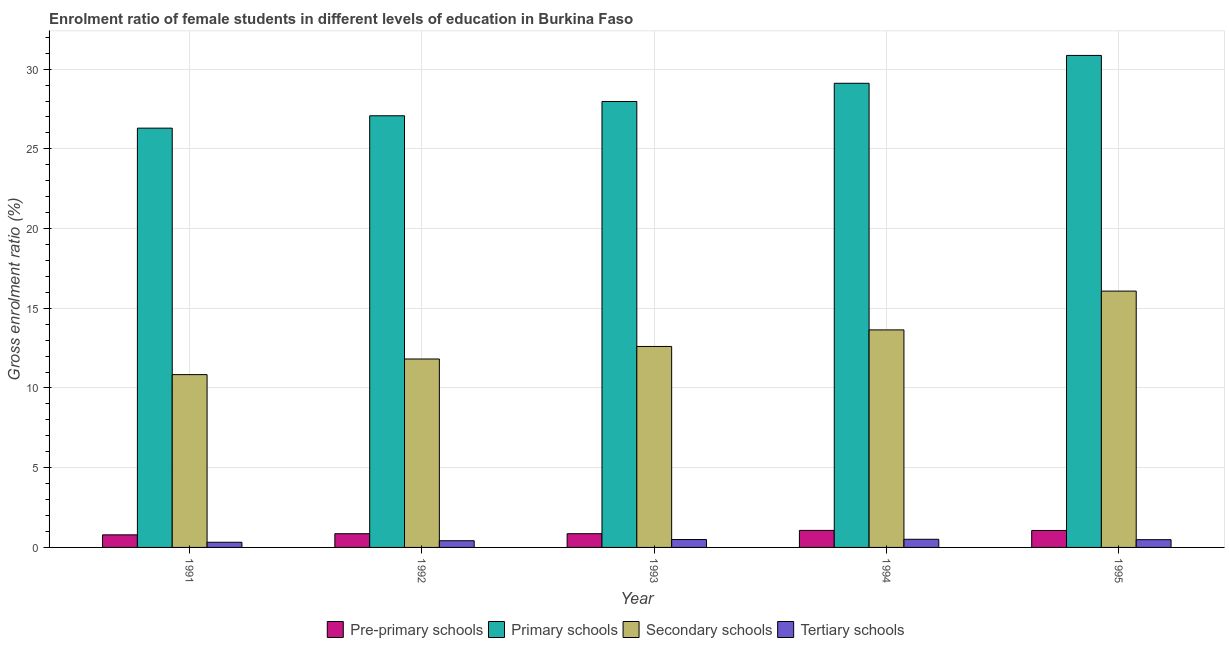Are the number of bars per tick equal to the number of legend labels?
Offer a very short reply. Yes. How many bars are there on the 5th tick from the left?
Provide a short and direct response. 4. How many bars are there on the 2nd tick from the right?
Offer a terse response. 4. What is the gross enrolment ratio(male) in tertiary schools in 1993?
Your answer should be very brief. 0.49. Across all years, what is the maximum gross enrolment ratio(male) in pre-primary schools?
Keep it short and to the point. 1.07. Across all years, what is the minimum gross enrolment ratio(male) in secondary schools?
Your answer should be compact. 10.84. In which year was the gross enrolment ratio(male) in pre-primary schools maximum?
Keep it short and to the point. 1994. In which year was the gross enrolment ratio(male) in secondary schools minimum?
Your answer should be compact. 1991. What is the total gross enrolment ratio(male) in secondary schools in the graph?
Your answer should be compact. 64.98. What is the difference between the gross enrolment ratio(male) in tertiary schools in 1992 and that in 1993?
Give a very brief answer. -0.08. What is the difference between the gross enrolment ratio(male) in tertiary schools in 1992 and the gross enrolment ratio(male) in secondary schools in 1991?
Offer a terse response. 0.1. What is the average gross enrolment ratio(male) in primary schools per year?
Offer a very short reply. 28.26. In how many years, is the gross enrolment ratio(male) in tertiary schools greater than 30 %?
Your response must be concise. 0. What is the ratio of the gross enrolment ratio(male) in primary schools in 1992 to that in 1995?
Keep it short and to the point. 0.88. What is the difference between the highest and the second highest gross enrolment ratio(male) in secondary schools?
Offer a very short reply. 2.43. What is the difference between the highest and the lowest gross enrolment ratio(male) in primary schools?
Your answer should be very brief. 4.56. What does the 2nd bar from the left in 1991 represents?
Provide a short and direct response. Primary schools. What does the 2nd bar from the right in 1995 represents?
Your answer should be very brief. Secondary schools. How many bars are there?
Keep it short and to the point. 20. Are all the bars in the graph horizontal?
Make the answer very short. No. What is the difference between two consecutive major ticks on the Y-axis?
Your answer should be very brief. 5. Does the graph contain grids?
Offer a very short reply. Yes. How are the legend labels stacked?
Your answer should be very brief. Horizontal. What is the title of the graph?
Ensure brevity in your answer.  Enrolment ratio of female students in different levels of education in Burkina Faso. Does "Sweden" appear as one of the legend labels in the graph?
Your answer should be compact. No. What is the Gross enrolment ratio (%) in Pre-primary schools in 1991?
Provide a short and direct response. 0.79. What is the Gross enrolment ratio (%) of Primary schools in 1991?
Ensure brevity in your answer.  26.3. What is the Gross enrolment ratio (%) in Secondary schools in 1991?
Provide a short and direct response. 10.84. What is the Gross enrolment ratio (%) of Tertiary schools in 1991?
Provide a short and direct response. 0.32. What is the Gross enrolment ratio (%) of Pre-primary schools in 1992?
Offer a very short reply. 0.86. What is the Gross enrolment ratio (%) in Primary schools in 1992?
Your response must be concise. 27.07. What is the Gross enrolment ratio (%) of Secondary schools in 1992?
Make the answer very short. 11.82. What is the Gross enrolment ratio (%) in Tertiary schools in 1992?
Provide a short and direct response. 0.42. What is the Gross enrolment ratio (%) of Pre-primary schools in 1993?
Give a very brief answer. 0.86. What is the Gross enrolment ratio (%) in Primary schools in 1993?
Provide a succinct answer. 27.97. What is the Gross enrolment ratio (%) in Secondary schools in 1993?
Your answer should be compact. 12.61. What is the Gross enrolment ratio (%) of Tertiary schools in 1993?
Offer a very short reply. 0.49. What is the Gross enrolment ratio (%) in Pre-primary schools in 1994?
Provide a succinct answer. 1.07. What is the Gross enrolment ratio (%) of Primary schools in 1994?
Your answer should be very brief. 29.11. What is the Gross enrolment ratio (%) in Secondary schools in 1994?
Provide a succinct answer. 13.64. What is the Gross enrolment ratio (%) of Tertiary schools in 1994?
Make the answer very short. 0.51. What is the Gross enrolment ratio (%) of Pre-primary schools in 1995?
Provide a short and direct response. 1.06. What is the Gross enrolment ratio (%) in Primary schools in 1995?
Provide a succinct answer. 30.86. What is the Gross enrolment ratio (%) in Secondary schools in 1995?
Offer a very short reply. 16.08. What is the Gross enrolment ratio (%) of Tertiary schools in 1995?
Keep it short and to the point. 0.49. Across all years, what is the maximum Gross enrolment ratio (%) in Pre-primary schools?
Your answer should be compact. 1.07. Across all years, what is the maximum Gross enrolment ratio (%) of Primary schools?
Ensure brevity in your answer.  30.86. Across all years, what is the maximum Gross enrolment ratio (%) of Secondary schools?
Keep it short and to the point. 16.08. Across all years, what is the maximum Gross enrolment ratio (%) in Tertiary schools?
Your response must be concise. 0.51. Across all years, what is the minimum Gross enrolment ratio (%) in Pre-primary schools?
Your answer should be compact. 0.79. Across all years, what is the minimum Gross enrolment ratio (%) in Primary schools?
Offer a terse response. 26.3. Across all years, what is the minimum Gross enrolment ratio (%) in Secondary schools?
Ensure brevity in your answer.  10.84. Across all years, what is the minimum Gross enrolment ratio (%) in Tertiary schools?
Provide a short and direct response. 0.32. What is the total Gross enrolment ratio (%) in Pre-primary schools in the graph?
Give a very brief answer. 4.64. What is the total Gross enrolment ratio (%) of Primary schools in the graph?
Your answer should be compact. 141.31. What is the total Gross enrolment ratio (%) of Secondary schools in the graph?
Provide a short and direct response. 64.98. What is the total Gross enrolment ratio (%) of Tertiary schools in the graph?
Your answer should be very brief. 2.23. What is the difference between the Gross enrolment ratio (%) of Pre-primary schools in 1991 and that in 1992?
Ensure brevity in your answer.  -0.07. What is the difference between the Gross enrolment ratio (%) in Primary schools in 1991 and that in 1992?
Ensure brevity in your answer.  -0.78. What is the difference between the Gross enrolment ratio (%) of Secondary schools in 1991 and that in 1992?
Make the answer very short. -0.98. What is the difference between the Gross enrolment ratio (%) of Tertiary schools in 1991 and that in 1992?
Your answer should be very brief. -0.1. What is the difference between the Gross enrolment ratio (%) of Pre-primary schools in 1991 and that in 1993?
Your answer should be very brief. -0.07. What is the difference between the Gross enrolment ratio (%) in Primary schools in 1991 and that in 1993?
Offer a terse response. -1.67. What is the difference between the Gross enrolment ratio (%) of Secondary schools in 1991 and that in 1993?
Make the answer very short. -1.77. What is the difference between the Gross enrolment ratio (%) in Tertiary schools in 1991 and that in 1993?
Offer a terse response. -0.17. What is the difference between the Gross enrolment ratio (%) of Pre-primary schools in 1991 and that in 1994?
Keep it short and to the point. -0.28. What is the difference between the Gross enrolment ratio (%) in Primary schools in 1991 and that in 1994?
Provide a succinct answer. -2.81. What is the difference between the Gross enrolment ratio (%) in Secondary schools in 1991 and that in 1994?
Keep it short and to the point. -2.8. What is the difference between the Gross enrolment ratio (%) in Tertiary schools in 1991 and that in 1994?
Your answer should be compact. -0.19. What is the difference between the Gross enrolment ratio (%) of Pre-primary schools in 1991 and that in 1995?
Your response must be concise. -0.28. What is the difference between the Gross enrolment ratio (%) of Primary schools in 1991 and that in 1995?
Offer a terse response. -4.56. What is the difference between the Gross enrolment ratio (%) of Secondary schools in 1991 and that in 1995?
Offer a terse response. -5.24. What is the difference between the Gross enrolment ratio (%) of Tertiary schools in 1991 and that in 1995?
Make the answer very short. -0.16. What is the difference between the Gross enrolment ratio (%) in Pre-primary schools in 1992 and that in 1993?
Make the answer very short. -0. What is the difference between the Gross enrolment ratio (%) in Primary schools in 1992 and that in 1993?
Offer a terse response. -0.9. What is the difference between the Gross enrolment ratio (%) of Secondary schools in 1992 and that in 1993?
Give a very brief answer. -0.79. What is the difference between the Gross enrolment ratio (%) of Tertiary schools in 1992 and that in 1993?
Ensure brevity in your answer.  -0.08. What is the difference between the Gross enrolment ratio (%) of Pre-primary schools in 1992 and that in 1994?
Ensure brevity in your answer.  -0.21. What is the difference between the Gross enrolment ratio (%) in Primary schools in 1992 and that in 1994?
Your answer should be compact. -2.04. What is the difference between the Gross enrolment ratio (%) of Secondary schools in 1992 and that in 1994?
Give a very brief answer. -1.82. What is the difference between the Gross enrolment ratio (%) of Tertiary schools in 1992 and that in 1994?
Keep it short and to the point. -0.09. What is the difference between the Gross enrolment ratio (%) in Pre-primary schools in 1992 and that in 1995?
Your answer should be compact. -0.2. What is the difference between the Gross enrolment ratio (%) of Primary schools in 1992 and that in 1995?
Your response must be concise. -3.79. What is the difference between the Gross enrolment ratio (%) of Secondary schools in 1992 and that in 1995?
Your answer should be compact. -4.26. What is the difference between the Gross enrolment ratio (%) of Tertiary schools in 1992 and that in 1995?
Your answer should be very brief. -0.07. What is the difference between the Gross enrolment ratio (%) of Pre-primary schools in 1993 and that in 1994?
Keep it short and to the point. -0.21. What is the difference between the Gross enrolment ratio (%) of Primary schools in 1993 and that in 1994?
Give a very brief answer. -1.14. What is the difference between the Gross enrolment ratio (%) in Secondary schools in 1993 and that in 1994?
Your answer should be very brief. -1.04. What is the difference between the Gross enrolment ratio (%) in Tertiary schools in 1993 and that in 1994?
Ensure brevity in your answer.  -0.02. What is the difference between the Gross enrolment ratio (%) of Pre-primary schools in 1993 and that in 1995?
Offer a very short reply. -0.2. What is the difference between the Gross enrolment ratio (%) of Primary schools in 1993 and that in 1995?
Give a very brief answer. -2.89. What is the difference between the Gross enrolment ratio (%) of Secondary schools in 1993 and that in 1995?
Your response must be concise. -3.47. What is the difference between the Gross enrolment ratio (%) of Tertiary schools in 1993 and that in 1995?
Offer a terse response. 0.01. What is the difference between the Gross enrolment ratio (%) of Pre-primary schools in 1994 and that in 1995?
Your answer should be very brief. 0. What is the difference between the Gross enrolment ratio (%) of Primary schools in 1994 and that in 1995?
Offer a terse response. -1.75. What is the difference between the Gross enrolment ratio (%) of Secondary schools in 1994 and that in 1995?
Ensure brevity in your answer.  -2.43. What is the difference between the Gross enrolment ratio (%) in Tertiary schools in 1994 and that in 1995?
Your response must be concise. 0.02. What is the difference between the Gross enrolment ratio (%) of Pre-primary schools in 1991 and the Gross enrolment ratio (%) of Primary schools in 1992?
Provide a short and direct response. -26.29. What is the difference between the Gross enrolment ratio (%) in Pre-primary schools in 1991 and the Gross enrolment ratio (%) in Secondary schools in 1992?
Provide a succinct answer. -11.03. What is the difference between the Gross enrolment ratio (%) of Pre-primary schools in 1991 and the Gross enrolment ratio (%) of Tertiary schools in 1992?
Keep it short and to the point. 0.37. What is the difference between the Gross enrolment ratio (%) of Primary schools in 1991 and the Gross enrolment ratio (%) of Secondary schools in 1992?
Your answer should be compact. 14.48. What is the difference between the Gross enrolment ratio (%) of Primary schools in 1991 and the Gross enrolment ratio (%) of Tertiary schools in 1992?
Offer a very short reply. 25.88. What is the difference between the Gross enrolment ratio (%) in Secondary schools in 1991 and the Gross enrolment ratio (%) in Tertiary schools in 1992?
Keep it short and to the point. 10.42. What is the difference between the Gross enrolment ratio (%) in Pre-primary schools in 1991 and the Gross enrolment ratio (%) in Primary schools in 1993?
Give a very brief answer. -27.18. What is the difference between the Gross enrolment ratio (%) of Pre-primary schools in 1991 and the Gross enrolment ratio (%) of Secondary schools in 1993?
Your answer should be very brief. -11.82. What is the difference between the Gross enrolment ratio (%) in Pre-primary schools in 1991 and the Gross enrolment ratio (%) in Tertiary schools in 1993?
Your response must be concise. 0.29. What is the difference between the Gross enrolment ratio (%) of Primary schools in 1991 and the Gross enrolment ratio (%) of Secondary schools in 1993?
Offer a terse response. 13.69. What is the difference between the Gross enrolment ratio (%) in Primary schools in 1991 and the Gross enrolment ratio (%) in Tertiary schools in 1993?
Your answer should be very brief. 25.8. What is the difference between the Gross enrolment ratio (%) of Secondary schools in 1991 and the Gross enrolment ratio (%) of Tertiary schools in 1993?
Your response must be concise. 10.34. What is the difference between the Gross enrolment ratio (%) of Pre-primary schools in 1991 and the Gross enrolment ratio (%) of Primary schools in 1994?
Your answer should be very brief. -28.32. What is the difference between the Gross enrolment ratio (%) of Pre-primary schools in 1991 and the Gross enrolment ratio (%) of Secondary schools in 1994?
Give a very brief answer. -12.85. What is the difference between the Gross enrolment ratio (%) of Pre-primary schools in 1991 and the Gross enrolment ratio (%) of Tertiary schools in 1994?
Your answer should be very brief. 0.28. What is the difference between the Gross enrolment ratio (%) in Primary schools in 1991 and the Gross enrolment ratio (%) in Secondary schools in 1994?
Your answer should be compact. 12.65. What is the difference between the Gross enrolment ratio (%) in Primary schools in 1991 and the Gross enrolment ratio (%) in Tertiary schools in 1994?
Your answer should be very brief. 25.79. What is the difference between the Gross enrolment ratio (%) of Secondary schools in 1991 and the Gross enrolment ratio (%) of Tertiary schools in 1994?
Provide a succinct answer. 10.33. What is the difference between the Gross enrolment ratio (%) of Pre-primary schools in 1991 and the Gross enrolment ratio (%) of Primary schools in 1995?
Your response must be concise. -30.07. What is the difference between the Gross enrolment ratio (%) in Pre-primary schools in 1991 and the Gross enrolment ratio (%) in Secondary schools in 1995?
Ensure brevity in your answer.  -15.29. What is the difference between the Gross enrolment ratio (%) of Pre-primary schools in 1991 and the Gross enrolment ratio (%) of Tertiary schools in 1995?
Your response must be concise. 0.3. What is the difference between the Gross enrolment ratio (%) in Primary schools in 1991 and the Gross enrolment ratio (%) in Secondary schools in 1995?
Offer a terse response. 10.22. What is the difference between the Gross enrolment ratio (%) of Primary schools in 1991 and the Gross enrolment ratio (%) of Tertiary schools in 1995?
Provide a succinct answer. 25.81. What is the difference between the Gross enrolment ratio (%) in Secondary schools in 1991 and the Gross enrolment ratio (%) in Tertiary schools in 1995?
Provide a short and direct response. 10.35. What is the difference between the Gross enrolment ratio (%) of Pre-primary schools in 1992 and the Gross enrolment ratio (%) of Primary schools in 1993?
Offer a terse response. -27.11. What is the difference between the Gross enrolment ratio (%) in Pre-primary schools in 1992 and the Gross enrolment ratio (%) in Secondary schools in 1993?
Offer a very short reply. -11.75. What is the difference between the Gross enrolment ratio (%) in Pre-primary schools in 1992 and the Gross enrolment ratio (%) in Tertiary schools in 1993?
Your response must be concise. 0.37. What is the difference between the Gross enrolment ratio (%) of Primary schools in 1992 and the Gross enrolment ratio (%) of Secondary schools in 1993?
Provide a succinct answer. 14.47. What is the difference between the Gross enrolment ratio (%) of Primary schools in 1992 and the Gross enrolment ratio (%) of Tertiary schools in 1993?
Provide a short and direct response. 26.58. What is the difference between the Gross enrolment ratio (%) in Secondary schools in 1992 and the Gross enrolment ratio (%) in Tertiary schools in 1993?
Provide a succinct answer. 11.32. What is the difference between the Gross enrolment ratio (%) of Pre-primary schools in 1992 and the Gross enrolment ratio (%) of Primary schools in 1994?
Offer a terse response. -28.25. What is the difference between the Gross enrolment ratio (%) in Pre-primary schools in 1992 and the Gross enrolment ratio (%) in Secondary schools in 1994?
Your answer should be compact. -12.78. What is the difference between the Gross enrolment ratio (%) of Pre-primary schools in 1992 and the Gross enrolment ratio (%) of Tertiary schools in 1994?
Ensure brevity in your answer.  0.35. What is the difference between the Gross enrolment ratio (%) of Primary schools in 1992 and the Gross enrolment ratio (%) of Secondary schools in 1994?
Keep it short and to the point. 13.43. What is the difference between the Gross enrolment ratio (%) in Primary schools in 1992 and the Gross enrolment ratio (%) in Tertiary schools in 1994?
Your response must be concise. 26.56. What is the difference between the Gross enrolment ratio (%) in Secondary schools in 1992 and the Gross enrolment ratio (%) in Tertiary schools in 1994?
Make the answer very short. 11.31. What is the difference between the Gross enrolment ratio (%) in Pre-primary schools in 1992 and the Gross enrolment ratio (%) in Primary schools in 1995?
Provide a succinct answer. -30. What is the difference between the Gross enrolment ratio (%) in Pre-primary schools in 1992 and the Gross enrolment ratio (%) in Secondary schools in 1995?
Make the answer very short. -15.22. What is the difference between the Gross enrolment ratio (%) in Pre-primary schools in 1992 and the Gross enrolment ratio (%) in Tertiary schools in 1995?
Your answer should be compact. 0.37. What is the difference between the Gross enrolment ratio (%) in Primary schools in 1992 and the Gross enrolment ratio (%) in Secondary schools in 1995?
Offer a very short reply. 11. What is the difference between the Gross enrolment ratio (%) of Primary schools in 1992 and the Gross enrolment ratio (%) of Tertiary schools in 1995?
Give a very brief answer. 26.59. What is the difference between the Gross enrolment ratio (%) in Secondary schools in 1992 and the Gross enrolment ratio (%) in Tertiary schools in 1995?
Offer a very short reply. 11.33. What is the difference between the Gross enrolment ratio (%) of Pre-primary schools in 1993 and the Gross enrolment ratio (%) of Primary schools in 1994?
Your answer should be very brief. -28.25. What is the difference between the Gross enrolment ratio (%) in Pre-primary schools in 1993 and the Gross enrolment ratio (%) in Secondary schools in 1994?
Your response must be concise. -12.78. What is the difference between the Gross enrolment ratio (%) of Pre-primary schools in 1993 and the Gross enrolment ratio (%) of Tertiary schools in 1994?
Ensure brevity in your answer.  0.35. What is the difference between the Gross enrolment ratio (%) of Primary schools in 1993 and the Gross enrolment ratio (%) of Secondary schools in 1994?
Provide a succinct answer. 14.33. What is the difference between the Gross enrolment ratio (%) of Primary schools in 1993 and the Gross enrolment ratio (%) of Tertiary schools in 1994?
Provide a succinct answer. 27.46. What is the difference between the Gross enrolment ratio (%) in Secondary schools in 1993 and the Gross enrolment ratio (%) in Tertiary schools in 1994?
Keep it short and to the point. 12.09. What is the difference between the Gross enrolment ratio (%) in Pre-primary schools in 1993 and the Gross enrolment ratio (%) in Primary schools in 1995?
Offer a very short reply. -30. What is the difference between the Gross enrolment ratio (%) of Pre-primary schools in 1993 and the Gross enrolment ratio (%) of Secondary schools in 1995?
Make the answer very short. -15.22. What is the difference between the Gross enrolment ratio (%) in Pre-primary schools in 1993 and the Gross enrolment ratio (%) in Tertiary schools in 1995?
Ensure brevity in your answer.  0.38. What is the difference between the Gross enrolment ratio (%) of Primary schools in 1993 and the Gross enrolment ratio (%) of Secondary schools in 1995?
Provide a short and direct response. 11.89. What is the difference between the Gross enrolment ratio (%) of Primary schools in 1993 and the Gross enrolment ratio (%) of Tertiary schools in 1995?
Your response must be concise. 27.48. What is the difference between the Gross enrolment ratio (%) in Secondary schools in 1993 and the Gross enrolment ratio (%) in Tertiary schools in 1995?
Your response must be concise. 12.12. What is the difference between the Gross enrolment ratio (%) of Pre-primary schools in 1994 and the Gross enrolment ratio (%) of Primary schools in 1995?
Give a very brief answer. -29.79. What is the difference between the Gross enrolment ratio (%) in Pre-primary schools in 1994 and the Gross enrolment ratio (%) in Secondary schools in 1995?
Your answer should be compact. -15.01. What is the difference between the Gross enrolment ratio (%) in Pre-primary schools in 1994 and the Gross enrolment ratio (%) in Tertiary schools in 1995?
Provide a short and direct response. 0.58. What is the difference between the Gross enrolment ratio (%) of Primary schools in 1994 and the Gross enrolment ratio (%) of Secondary schools in 1995?
Make the answer very short. 13.03. What is the difference between the Gross enrolment ratio (%) in Primary schools in 1994 and the Gross enrolment ratio (%) in Tertiary schools in 1995?
Make the answer very short. 28.63. What is the difference between the Gross enrolment ratio (%) of Secondary schools in 1994 and the Gross enrolment ratio (%) of Tertiary schools in 1995?
Make the answer very short. 13.16. What is the average Gross enrolment ratio (%) in Pre-primary schools per year?
Provide a short and direct response. 0.93. What is the average Gross enrolment ratio (%) of Primary schools per year?
Provide a succinct answer. 28.26. What is the average Gross enrolment ratio (%) of Secondary schools per year?
Give a very brief answer. 13. What is the average Gross enrolment ratio (%) in Tertiary schools per year?
Keep it short and to the point. 0.45. In the year 1991, what is the difference between the Gross enrolment ratio (%) in Pre-primary schools and Gross enrolment ratio (%) in Primary schools?
Your response must be concise. -25.51. In the year 1991, what is the difference between the Gross enrolment ratio (%) in Pre-primary schools and Gross enrolment ratio (%) in Secondary schools?
Provide a short and direct response. -10.05. In the year 1991, what is the difference between the Gross enrolment ratio (%) in Pre-primary schools and Gross enrolment ratio (%) in Tertiary schools?
Your response must be concise. 0.46. In the year 1991, what is the difference between the Gross enrolment ratio (%) of Primary schools and Gross enrolment ratio (%) of Secondary schools?
Make the answer very short. 15.46. In the year 1991, what is the difference between the Gross enrolment ratio (%) of Primary schools and Gross enrolment ratio (%) of Tertiary schools?
Your answer should be compact. 25.97. In the year 1991, what is the difference between the Gross enrolment ratio (%) of Secondary schools and Gross enrolment ratio (%) of Tertiary schools?
Provide a short and direct response. 10.51. In the year 1992, what is the difference between the Gross enrolment ratio (%) of Pre-primary schools and Gross enrolment ratio (%) of Primary schools?
Make the answer very short. -26.21. In the year 1992, what is the difference between the Gross enrolment ratio (%) of Pre-primary schools and Gross enrolment ratio (%) of Secondary schools?
Give a very brief answer. -10.96. In the year 1992, what is the difference between the Gross enrolment ratio (%) of Pre-primary schools and Gross enrolment ratio (%) of Tertiary schools?
Ensure brevity in your answer.  0.44. In the year 1992, what is the difference between the Gross enrolment ratio (%) in Primary schools and Gross enrolment ratio (%) in Secondary schools?
Your answer should be very brief. 15.26. In the year 1992, what is the difference between the Gross enrolment ratio (%) in Primary schools and Gross enrolment ratio (%) in Tertiary schools?
Provide a succinct answer. 26.65. In the year 1992, what is the difference between the Gross enrolment ratio (%) in Secondary schools and Gross enrolment ratio (%) in Tertiary schools?
Your answer should be very brief. 11.4. In the year 1993, what is the difference between the Gross enrolment ratio (%) of Pre-primary schools and Gross enrolment ratio (%) of Primary schools?
Provide a short and direct response. -27.11. In the year 1993, what is the difference between the Gross enrolment ratio (%) of Pre-primary schools and Gross enrolment ratio (%) of Secondary schools?
Your answer should be compact. -11.74. In the year 1993, what is the difference between the Gross enrolment ratio (%) of Pre-primary schools and Gross enrolment ratio (%) of Tertiary schools?
Keep it short and to the point. 0.37. In the year 1993, what is the difference between the Gross enrolment ratio (%) of Primary schools and Gross enrolment ratio (%) of Secondary schools?
Keep it short and to the point. 15.37. In the year 1993, what is the difference between the Gross enrolment ratio (%) in Primary schools and Gross enrolment ratio (%) in Tertiary schools?
Give a very brief answer. 27.48. In the year 1993, what is the difference between the Gross enrolment ratio (%) in Secondary schools and Gross enrolment ratio (%) in Tertiary schools?
Give a very brief answer. 12.11. In the year 1994, what is the difference between the Gross enrolment ratio (%) of Pre-primary schools and Gross enrolment ratio (%) of Primary schools?
Your answer should be compact. -28.04. In the year 1994, what is the difference between the Gross enrolment ratio (%) of Pre-primary schools and Gross enrolment ratio (%) of Secondary schools?
Give a very brief answer. -12.57. In the year 1994, what is the difference between the Gross enrolment ratio (%) of Pre-primary schools and Gross enrolment ratio (%) of Tertiary schools?
Give a very brief answer. 0.56. In the year 1994, what is the difference between the Gross enrolment ratio (%) of Primary schools and Gross enrolment ratio (%) of Secondary schools?
Provide a short and direct response. 15.47. In the year 1994, what is the difference between the Gross enrolment ratio (%) in Primary schools and Gross enrolment ratio (%) in Tertiary schools?
Keep it short and to the point. 28.6. In the year 1994, what is the difference between the Gross enrolment ratio (%) in Secondary schools and Gross enrolment ratio (%) in Tertiary schools?
Your answer should be very brief. 13.13. In the year 1995, what is the difference between the Gross enrolment ratio (%) of Pre-primary schools and Gross enrolment ratio (%) of Primary schools?
Offer a terse response. -29.79. In the year 1995, what is the difference between the Gross enrolment ratio (%) in Pre-primary schools and Gross enrolment ratio (%) in Secondary schools?
Keep it short and to the point. -15.01. In the year 1995, what is the difference between the Gross enrolment ratio (%) in Pre-primary schools and Gross enrolment ratio (%) in Tertiary schools?
Your response must be concise. 0.58. In the year 1995, what is the difference between the Gross enrolment ratio (%) in Primary schools and Gross enrolment ratio (%) in Secondary schools?
Your answer should be very brief. 14.78. In the year 1995, what is the difference between the Gross enrolment ratio (%) of Primary schools and Gross enrolment ratio (%) of Tertiary schools?
Keep it short and to the point. 30.37. In the year 1995, what is the difference between the Gross enrolment ratio (%) of Secondary schools and Gross enrolment ratio (%) of Tertiary schools?
Keep it short and to the point. 15.59. What is the ratio of the Gross enrolment ratio (%) of Pre-primary schools in 1991 to that in 1992?
Give a very brief answer. 0.92. What is the ratio of the Gross enrolment ratio (%) in Primary schools in 1991 to that in 1992?
Offer a very short reply. 0.97. What is the ratio of the Gross enrolment ratio (%) in Secondary schools in 1991 to that in 1992?
Your answer should be very brief. 0.92. What is the ratio of the Gross enrolment ratio (%) in Tertiary schools in 1991 to that in 1992?
Provide a short and direct response. 0.77. What is the ratio of the Gross enrolment ratio (%) of Pre-primary schools in 1991 to that in 1993?
Your answer should be compact. 0.92. What is the ratio of the Gross enrolment ratio (%) in Primary schools in 1991 to that in 1993?
Your answer should be very brief. 0.94. What is the ratio of the Gross enrolment ratio (%) of Secondary schools in 1991 to that in 1993?
Give a very brief answer. 0.86. What is the ratio of the Gross enrolment ratio (%) in Tertiary schools in 1991 to that in 1993?
Provide a short and direct response. 0.65. What is the ratio of the Gross enrolment ratio (%) of Pre-primary schools in 1991 to that in 1994?
Make the answer very short. 0.74. What is the ratio of the Gross enrolment ratio (%) in Primary schools in 1991 to that in 1994?
Keep it short and to the point. 0.9. What is the ratio of the Gross enrolment ratio (%) in Secondary schools in 1991 to that in 1994?
Your response must be concise. 0.79. What is the ratio of the Gross enrolment ratio (%) in Tertiary schools in 1991 to that in 1994?
Give a very brief answer. 0.63. What is the ratio of the Gross enrolment ratio (%) of Pre-primary schools in 1991 to that in 1995?
Provide a succinct answer. 0.74. What is the ratio of the Gross enrolment ratio (%) of Primary schools in 1991 to that in 1995?
Give a very brief answer. 0.85. What is the ratio of the Gross enrolment ratio (%) in Secondary schools in 1991 to that in 1995?
Keep it short and to the point. 0.67. What is the ratio of the Gross enrolment ratio (%) in Tertiary schools in 1991 to that in 1995?
Offer a terse response. 0.67. What is the ratio of the Gross enrolment ratio (%) in Secondary schools in 1992 to that in 1993?
Your answer should be compact. 0.94. What is the ratio of the Gross enrolment ratio (%) in Tertiary schools in 1992 to that in 1993?
Your answer should be very brief. 0.85. What is the ratio of the Gross enrolment ratio (%) in Pre-primary schools in 1992 to that in 1994?
Give a very brief answer. 0.8. What is the ratio of the Gross enrolment ratio (%) of Primary schools in 1992 to that in 1994?
Your response must be concise. 0.93. What is the ratio of the Gross enrolment ratio (%) of Secondary schools in 1992 to that in 1994?
Make the answer very short. 0.87. What is the ratio of the Gross enrolment ratio (%) in Tertiary schools in 1992 to that in 1994?
Your answer should be very brief. 0.82. What is the ratio of the Gross enrolment ratio (%) in Pre-primary schools in 1992 to that in 1995?
Your answer should be very brief. 0.81. What is the ratio of the Gross enrolment ratio (%) of Primary schools in 1992 to that in 1995?
Your answer should be compact. 0.88. What is the ratio of the Gross enrolment ratio (%) in Secondary schools in 1992 to that in 1995?
Keep it short and to the point. 0.74. What is the ratio of the Gross enrolment ratio (%) in Tertiary schools in 1992 to that in 1995?
Give a very brief answer. 0.86. What is the ratio of the Gross enrolment ratio (%) in Pre-primary schools in 1993 to that in 1994?
Your answer should be compact. 0.81. What is the ratio of the Gross enrolment ratio (%) in Primary schools in 1993 to that in 1994?
Offer a terse response. 0.96. What is the ratio of the Gross enrolment ratio (%) in Secondary schools in 1993 to that in 1994?
Keep it short and to the point. 0.92. What is the ratio of the Gross enrolment ratio (%) in Pre-primary schools in 1993 to that in 1995?
Provide a succinct answer. 0.81. What is the ratio of the Gross enrolment ratio (%) of Primary schools in 1993 to that in 1995?
Offer a very short reply. 0.91. What is the ratio of the Gross enrolment ratio (%) in Secondary schools in 1993 to that in 1995?
Offer a terse response. 0.78. What is the ratio of the Gross enrolment ratio (%) of Tertiary schools in 1993 to that in 1995?
Provide a succinct answer. 1.02. What is the ratio of the Gross enrolment ratio (%) in Pre-primary schools in 1994 to that in 1995?
Your response must be concise. 1. What is the ratio of the Gross enrolment ratio (%) in Primary schools in 1994 to that in 1995?
Offer a terse response. 0.94. What is the ratio of the Gross enrolment ratio (%) of Secondary schools in 1994 to that in 1995?
Your answer should be very brief. 0.85. What is the ratio of the Gross enrolment ratio (%) of Tertiary schools in 1994 to that in 1995?
Your answer should be very brief. 1.05. What is the difference between the highest and the second highest Gross enrolment ratio (%) of Pre-primary schools?
Ensure brevity in your answer.  0. What is the difference between the highest and the second highest Gross enrolment ratio (%) in Primary schools?
Provide a succinct answer. 1.75. What is the difference between the highest and the second highest Gross enrolment ratio (%) in Secondary schools?
Keep it short and to the point. 2.43. What is the difference between the highest and the second highest Gross enrolment ratio (%) of Tertiary schools?
Give a very brief answer. 0.02. What is the difference between the highest and the lowest Gross enrolment ratio (%) of Pre-primary schools?
Keep it short and to the point. 0.28. What is the difference between the highest and the lowest Gross enrolment ratio (%) in Primary schools?
Your answer should be compact. 4.56. What is the difference between the highest and the lowest Gross enrolment ratio (%) of Secondary schools?
Ensure brevity in your answer.  5.24. What is the difference between the highest and the lowest Gross enrolment ratio (%) in Tertiary schools?
Your answer should be very brief. 0.19. 